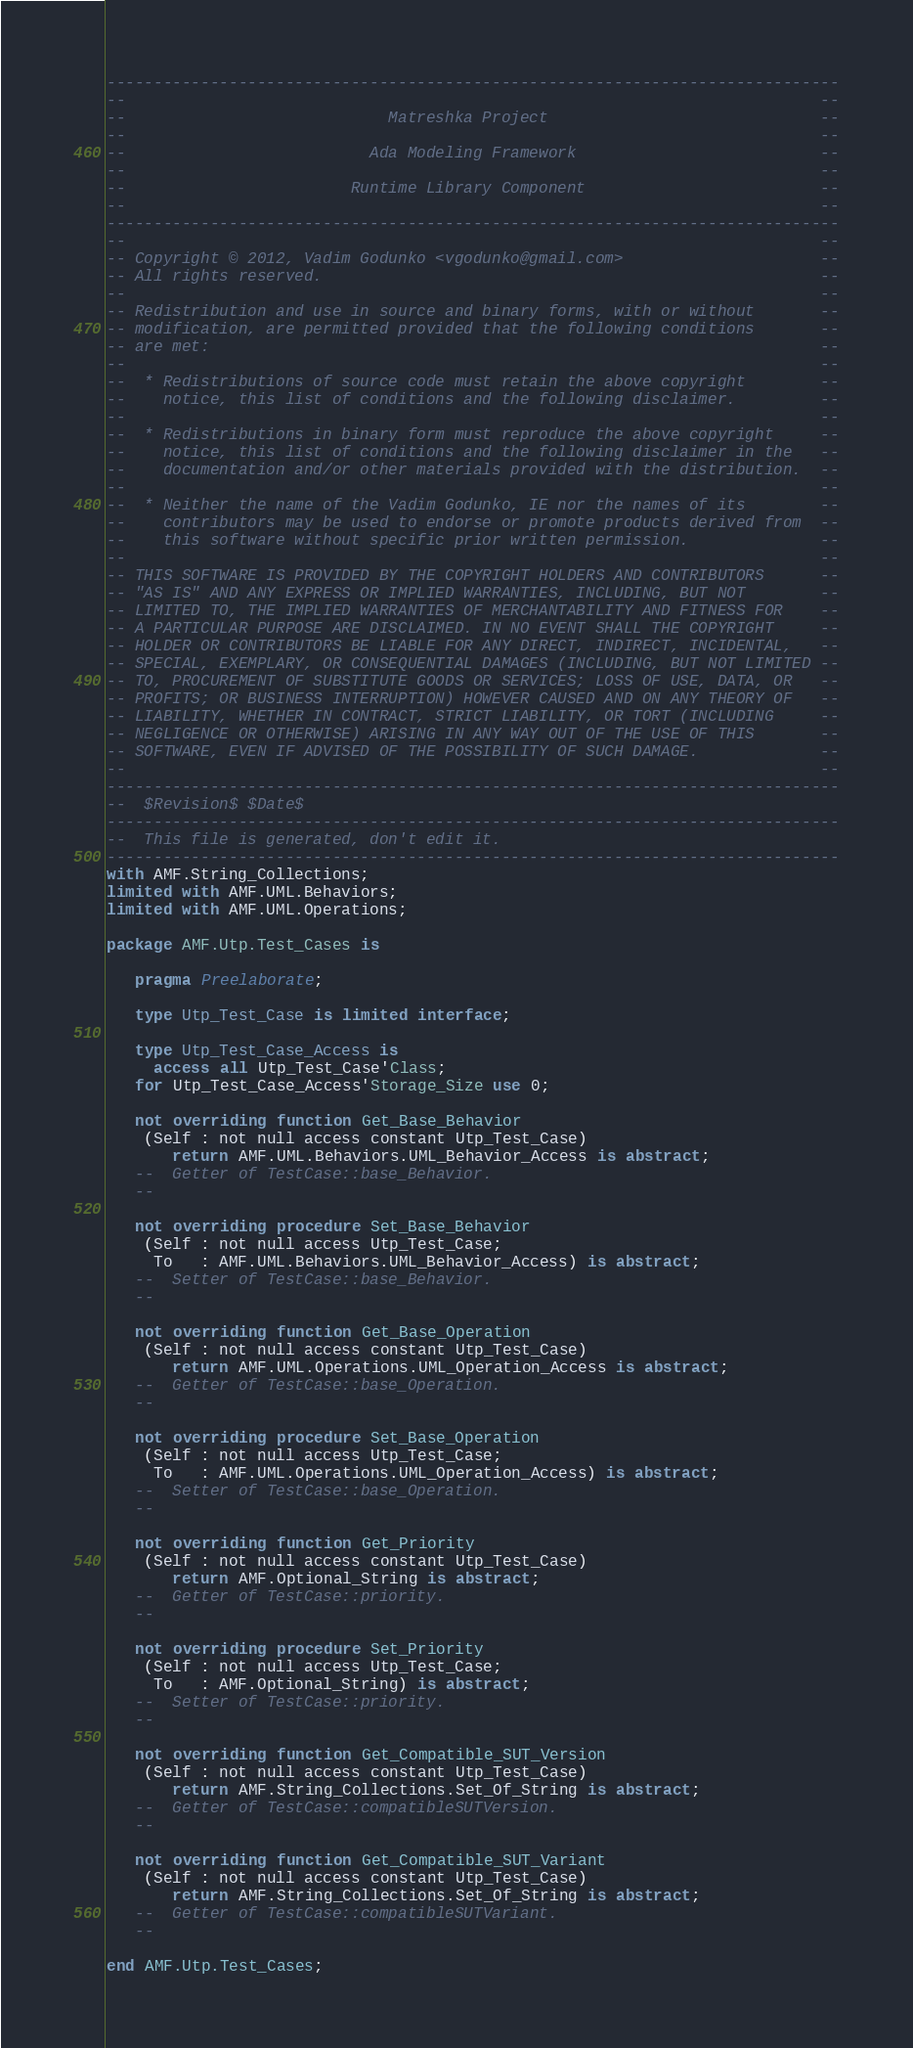<code> <loc_0><loc_0><loc_500><loc_500><_Ada_>------------------------------------------------------------------------------
--                                                                          --
--                            Matreshka Project                             --
--                                                                          --
--                          Ada Modeling Framework                          --
--                                                                          --
--                        Runtime Library Component                         --
--                                                                          --
------------------------------------------------------------------------------
--                                                                          --
-- Copyright © 2012, Vadim Godunko <vgodunko@gmail.com>                     --
-- All rights reserved.                                                     --
--                                                                          --
-- Redistribution and use in source and binary forms, with or without       --
-- modification, are permitted provided that the following conditions       --
-- are met:                                                                 --
--                                                                          --
--  * Redistributions of source code must retain the above copyright        --
--    notice, this list of conditions and the following disclaimer.         --
--                                                                          --
--  * Redistributions in binary form must reproduce the above copyright     --
--    notice, this list of conditions and the following disclaimer in the   --
--    documentation and/or other materials provided with the distribution.  --
--                                                                          --
--  * Neither the name of the Vadim Godunko, IE nor the names of its        --
--    contributors may be used to endorse or promote products derived from  --
--    this software without specific prior written permission.              --
--                                                                          --
-- THIS SOFTWARE IS PROVIDED BY THE COPYRIGHT HOLDERS AND CONTRIBUTORS      --
-- "AS IS" AND ANY EXPRESS OR IMPLIED WARRANTIES, INCLUDING, BUT NOT        --
-- LIMITED TO, THE IMPLIED WARRANTIES OF MERCHANTABILITY AND FITNESS FOR    --
-- A PARTICULAR PURPOSE ARE DISCLAIMED. IN NO EVENT SHALL THE COPYRIGHT     --
-- HOLDER OR CONTRIBUTORS BE LIABLE FOR ANY DIRECT, INDIRECT, INCIDENTAL,   --
-- SPECIAL, EXEMPLARY, OR CONSEQUENTIAL DAMAGES (INCLUDING, BUT NOT LIMITED --
-- TO, PROCUREMENT OF SUBSTITUTE GOODS OR SERVICES; LOSS OF USE, DATA, OR   --
-- PROFITS; OR BUSINESS INTERRUPTION) HOWEVER CAUSED AND ON ANY THEORY OF   --
-- LIABILITY, WHETHER IN CONTRACT, STRICT LIABILITY, OR TORT (INCLUDING     --
-- NEGLIGENCE OR OTHERWISE) ARISING IN ANY WAY OUT OF THE USE OF THIS       --
-- SOFTWARE, EVEN IF ADVISED OF THE POSSIBILITY OF SUCH DAMAGE.             --
--                                                                          --
------------------------------------------------------------------------------
--  $Revision$ $Date$
------------------------------------------------------------------------------
--  This file is generated, don't edit it.
------------------------------------------------------------------------------
with AMF.String_Collections;
limited with AMF.UML.Behaviors;
limited with AMF.UML.Operations;

package AMF.Utp.Test_Cases is

   pragma Preelaborate;

   type Utp_Test_Case is limited interface;

   type Utp_Test_Case_Access is
     access all Utp_Test_Case'Class;
   for Utp_Test_Case_Access'Storage_Size use 0;

   not overriding function Get_Base_Behavior
    (Self : not null access constant Utp_Test_Case)
       return AMF.UML.Behaviors.UML_Behavior_Access is abstract;
   --  Getter of TestCase::base_Behavior.
   --

   not overriding procedure Set_Base_Behavior
    (Self : not null access Utp_Test_Case;
     To   : AMF.UML.Behaviors.UML_Behavior_Access) is abstract;
   --  Setter of TestCase::base_Behavior.
   --

   not overriding function Get_Base_Operation
    (Self : not null access constant Utp_Test_Case)
       return AMF.UML.Operations.UML_Operation_Access is abstract;
   --  Getter of TestCase::base_Operation.
   --

   not overriding procedure Set_Base_Operation
    (Self : not null access Utp_Test_Case;
     To   : AMF.UML.Operations.UML_Operation_Access) is abstract;
   --  Setter of TestCase::base_Operation.
   --

   not overriding function Get_Priority
    (Self : not null access constant Utp_Test_Case)
       return AMF.Optional_String is abstract;
   --  Getter of TestCase::priority.
   --

   not overriding procedure Set_Priority
    (Self : not null access Utp_Test_Case;
     To   : AMF.Optional_String) is abstract;
   --  Setter of TestCase::priority.
   --

   not overriding function Get_Compatible_SUT_Version
    (Self : not null access constant Utp_Test_Case)
       return AMF.String_Collections.Set_Of_String is abstract;
   --  Getter of TestCase::compatibleSUTVersion.
   --

   not overriding function Get_Compatible_SUT_Variant
    (Self : not null access constant Utp_Test_Case)
       return AMF.String_Collections.Set_Of_String is abstract;
   --  Getter of TestCase::compatibleSUTVariant.
   --

end AMF.Utp.Test_Cases;
</code> 